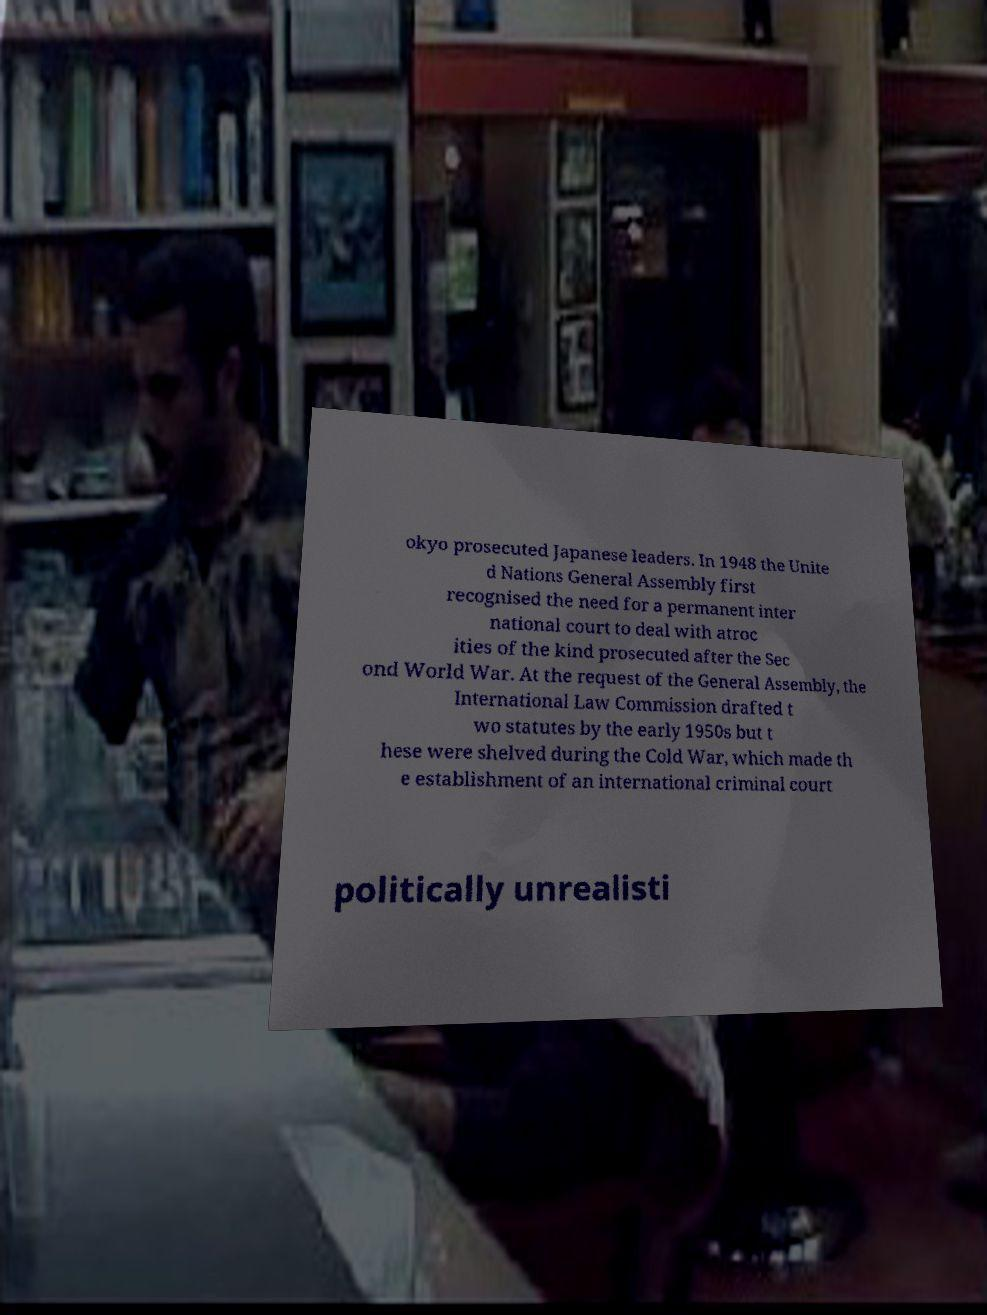For documentation purposes, I need the text within this image transcribed. Could you provide that? okyo prosecuted Japanese leaders. In 1948 the Unite d Nations General Assembly first recognised the need for a permanent inter national court to deal with atroc ities of the kind prosecuted after the Sec ond World War. At the request of the General Assembly, the International Law Commission drafted t wo statutes by the early 1950s but t hese were shelved during the Cold War, which made th e establishment of an international criminal court politically unrealisti 